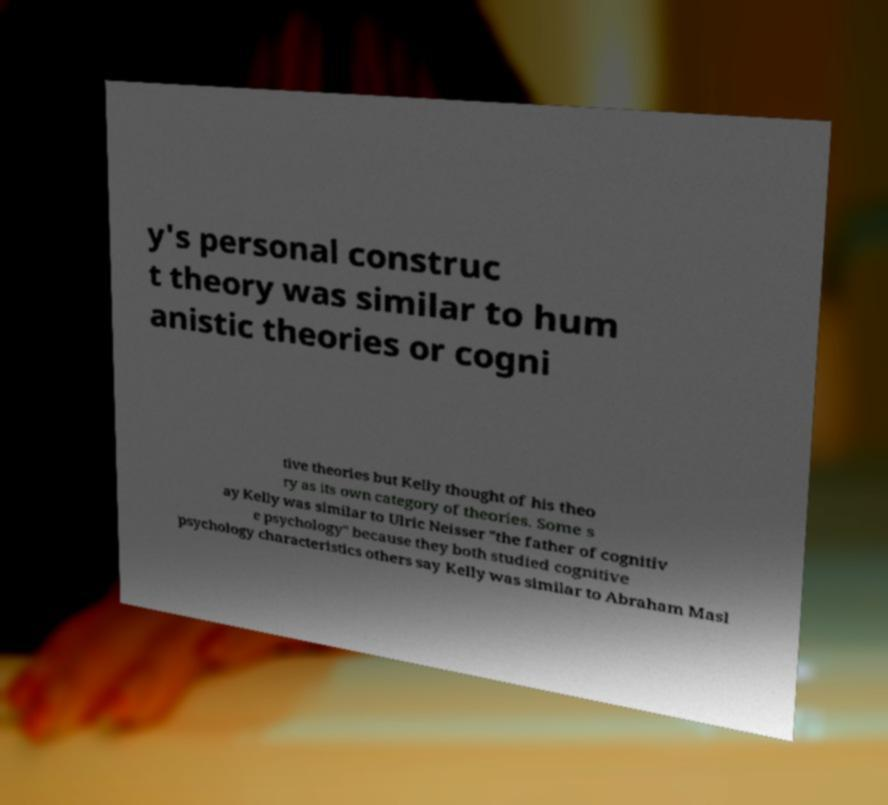What messages or text are displayed in this image? I need them in a readable, typed format. y's personal construc t theory was similar to hum anistic theories or cogni tive theories but Kelly thought of his theo ry as its own category of theories. Some s ay Kelly was similar to Ulric Neisser "the father of cognitiv e psychology" because they both studied cognitive psychology characteristics others say Kelly was similar to Abraham Masl 